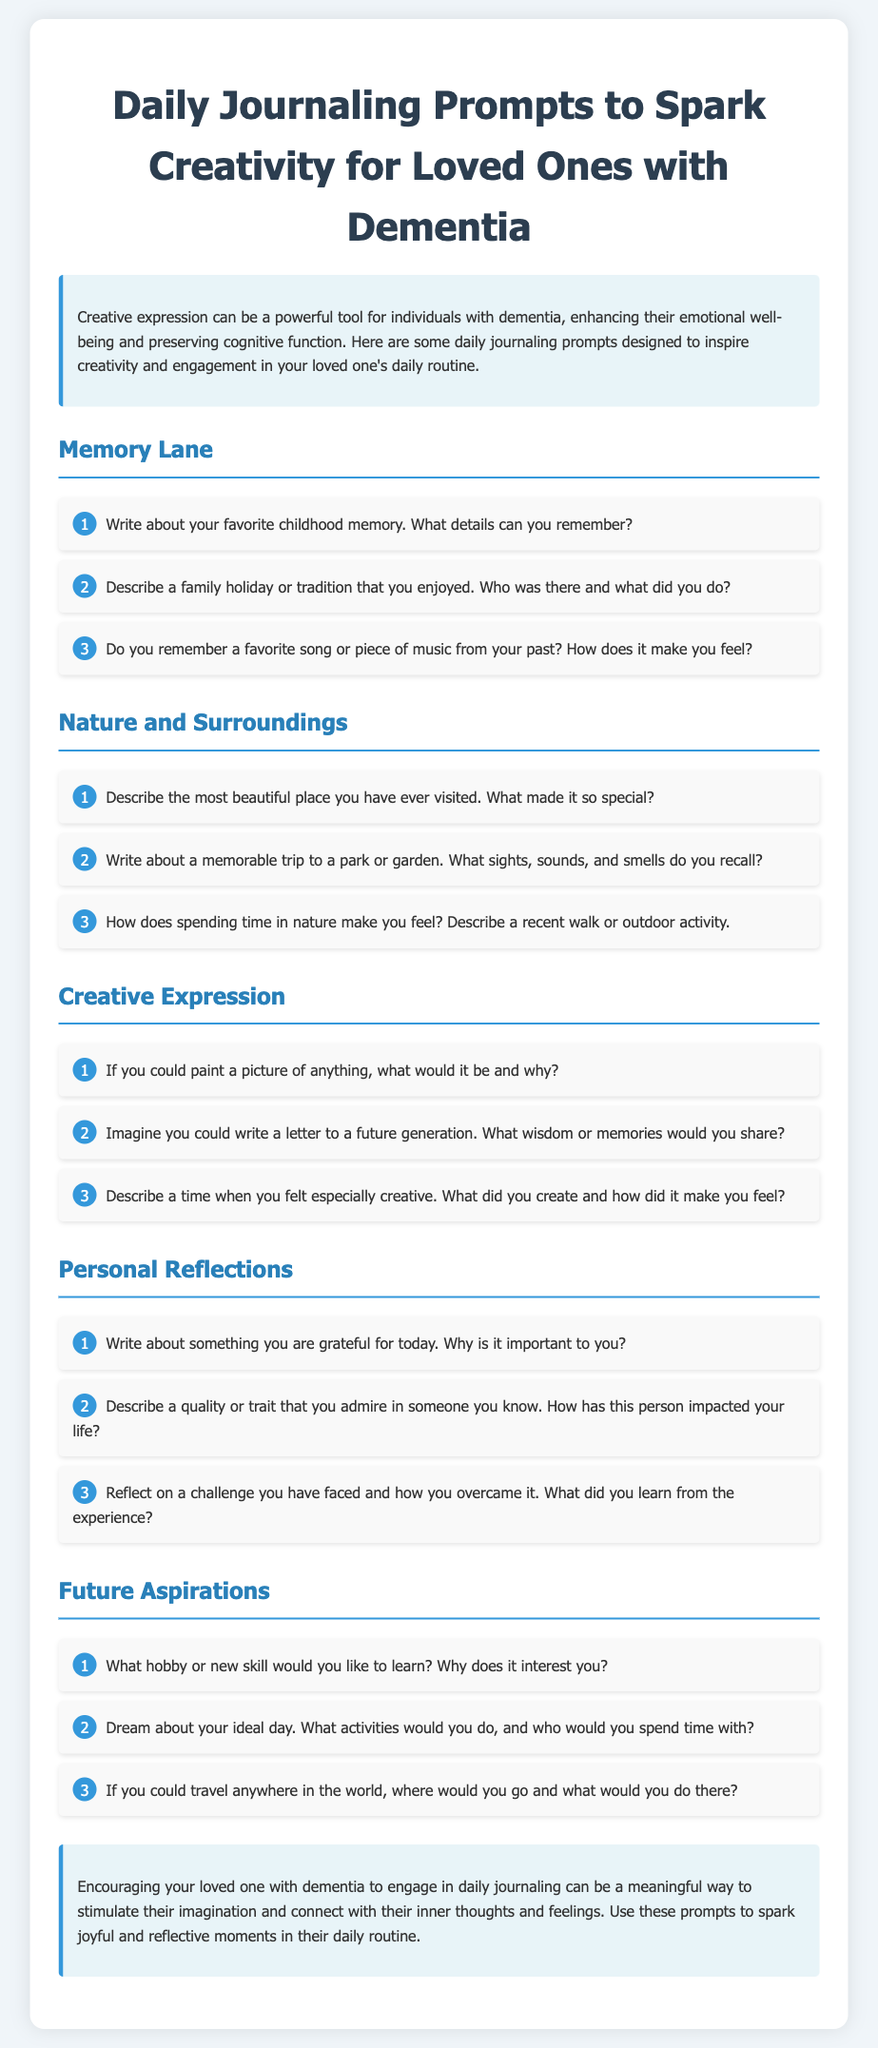What is the title of the document? The title is presented at the top of the document, summarizing its purpose.
Answer: Daily Journaling Prompts to Spark Creativity for Loved Ones with Dementia How many sections are in the document? The document consists of five different sections focusing on various themes.
Answer: 5 What is the first prompt under "Memory Lane"? The prompts are listed under each section; the first one is specifically mentioned.
Answer: Write about your favorite childhood memory. What details can you remember? What type of expression does the document encourage? The document focuses on a specific form of creative engagement for individuals with dementia.
Answer: Creative expression Which section includes a prompt about an ideal day? The prompt about dreaming of an ideal day is located in a specific section dedicated to aspirations.
Answer: Future Aspirations Describe one activity suggested in the "Personal Reflections" section. The Activities within this section provide opportunities for introspection and self-discovery.
Answer: Write about something you are grateful for today. Why is it important to you? What color is used for the section titles? The color used for the section titles can be inferred from the visual information in the document's style.
Answer: #2980b9 What is encouraged as a way to connect with inner thoughts? This specific activity is suggested as a meaningful engagement for individuals with dementia throughout the document.
Answer: Daily journaling 